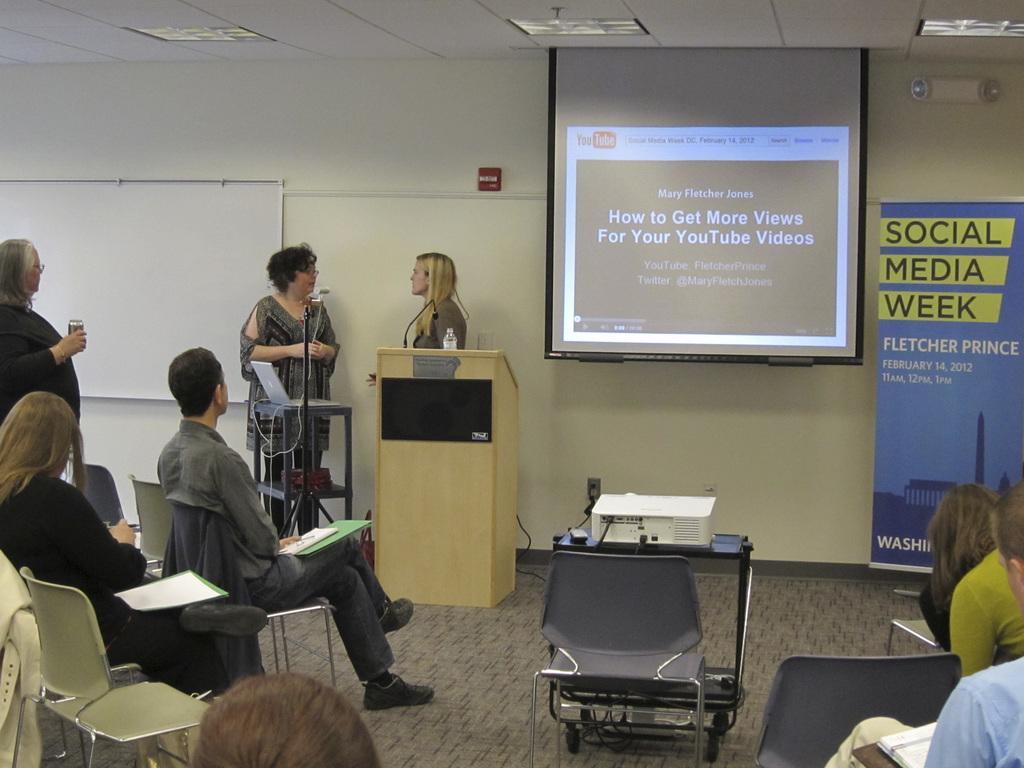Could you give a brief overview of what you see in this image? There is a group of people sitting on the chairs as we can see in the bottom left corner of this image and in the bottom right corner of this image as well. There are three women standing on the left side of this image. There is a make table in the middle of this image and there is a wall in the background. We can see a projector screen and a poster is on the right side of this image. There is a projector at the bottom of this image. 